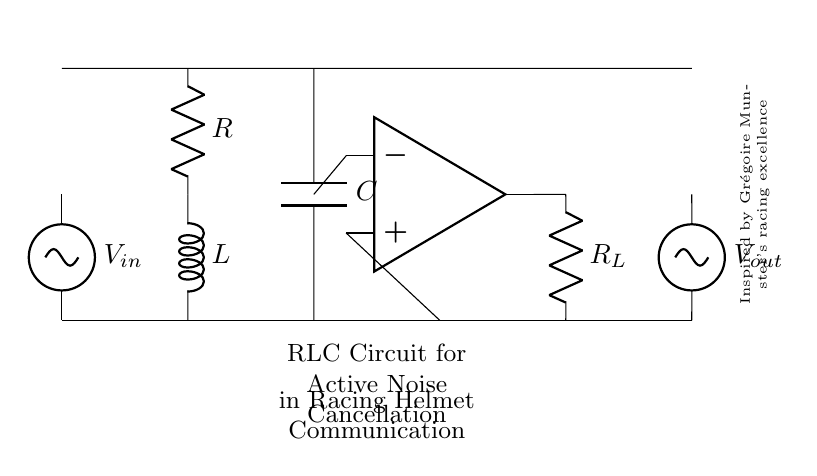What is the input voltage of this circuit? The input voltage is labeled as V_in in the diagram, indicating the voltage source connected at the start of the circuit.
Answer: V_in What type of components are present in this circuit? The components in the circuit include a resistor, inductor, capacitor, and an operational amplifier, each labeled clearly in the diagram.
Answer: Resistor, inductor, capacitor, operational amplifier What is the purpose of the operational amplifier in this RLC circuit? The operational amplifier amplifies the voltage level, which helps in active noise cancellation, suggesting its role in processing the signal received from the preceding RLC arrangement.
Answer: Amplification How many passive components are in this RLC circuit? The circuit contains three passive components: one resistor, one inductor, and one capacitor, each functioning to filter or shape the signal in response to varying frequencies.
Answer: Three What is the role of the capacitor in terms of frequency? The capacitor helps to block low-frequency signals while allowing higher frequencies to pass, functioning as a high-pass filter in the circuit behavior which is crucial for effective noise cancellation.
Answer: High-pass filter What is the function of the inductor in this RLC circuit? The inductor opposes changes in current, enabling it to store energy in a magnetic field and helps in shaping the frequency response of the entire circuit, particularly to attenuate unwanted noise frequencies.
Answer: Energy storage What circuit behavior does the combination of R, L, and C create in an active noise cancellation system? The combination of resistor, inductor, and capacitor creates a resonance effect at specific frequencies, allowing for the cancellation of certain unwanted noises, which is essential for enhancing communication in racing helmets.
Answer: Resonance effect 